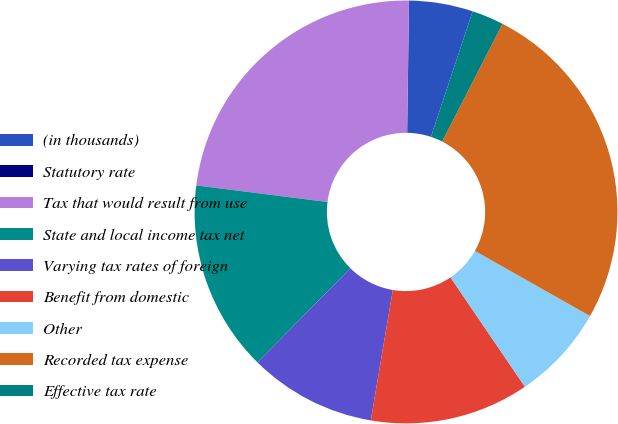<chart> <loc_0><loc_0><loc_500><loc_500><pie_chart><fcel>(in thousands)<fcel>Statutory rate<fcel>Tax that would result from use<fcel>State and local income tax net<fcel>Varying tax rates of foreign<fcel>Benefit from domestic<fcel>Other<fcel>Recorded tax expense<fcel>Effective tax rate<nl><fcel>4.87%<fcel>0.01%<fcel>23.22%<fcel>14.6%<fcel>9.74%<fcel>12.17%<fcel>7.3%<fcel>25.65%<fcel>2.44%<nl></chart> 